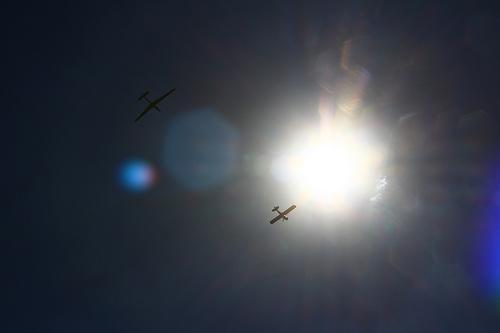How many planes are there?
Give a very brief answer. 1. 